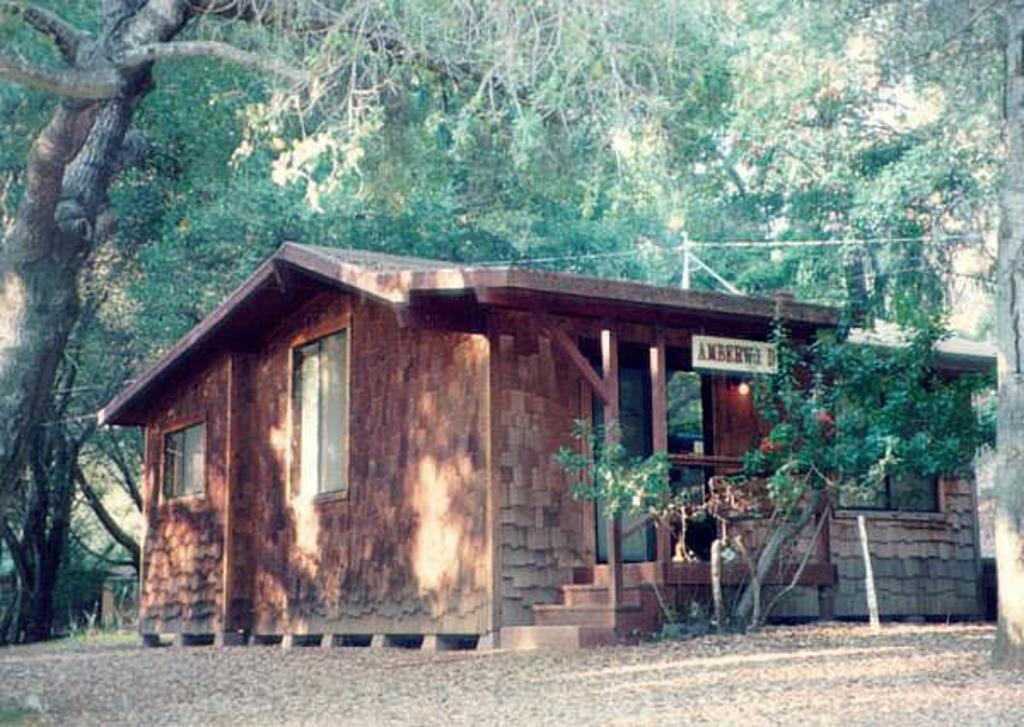Could you give a brief overview of what you see in this image? In the image we can see a plant. Behind the plant there is a house. Behind the house there are some trees. 